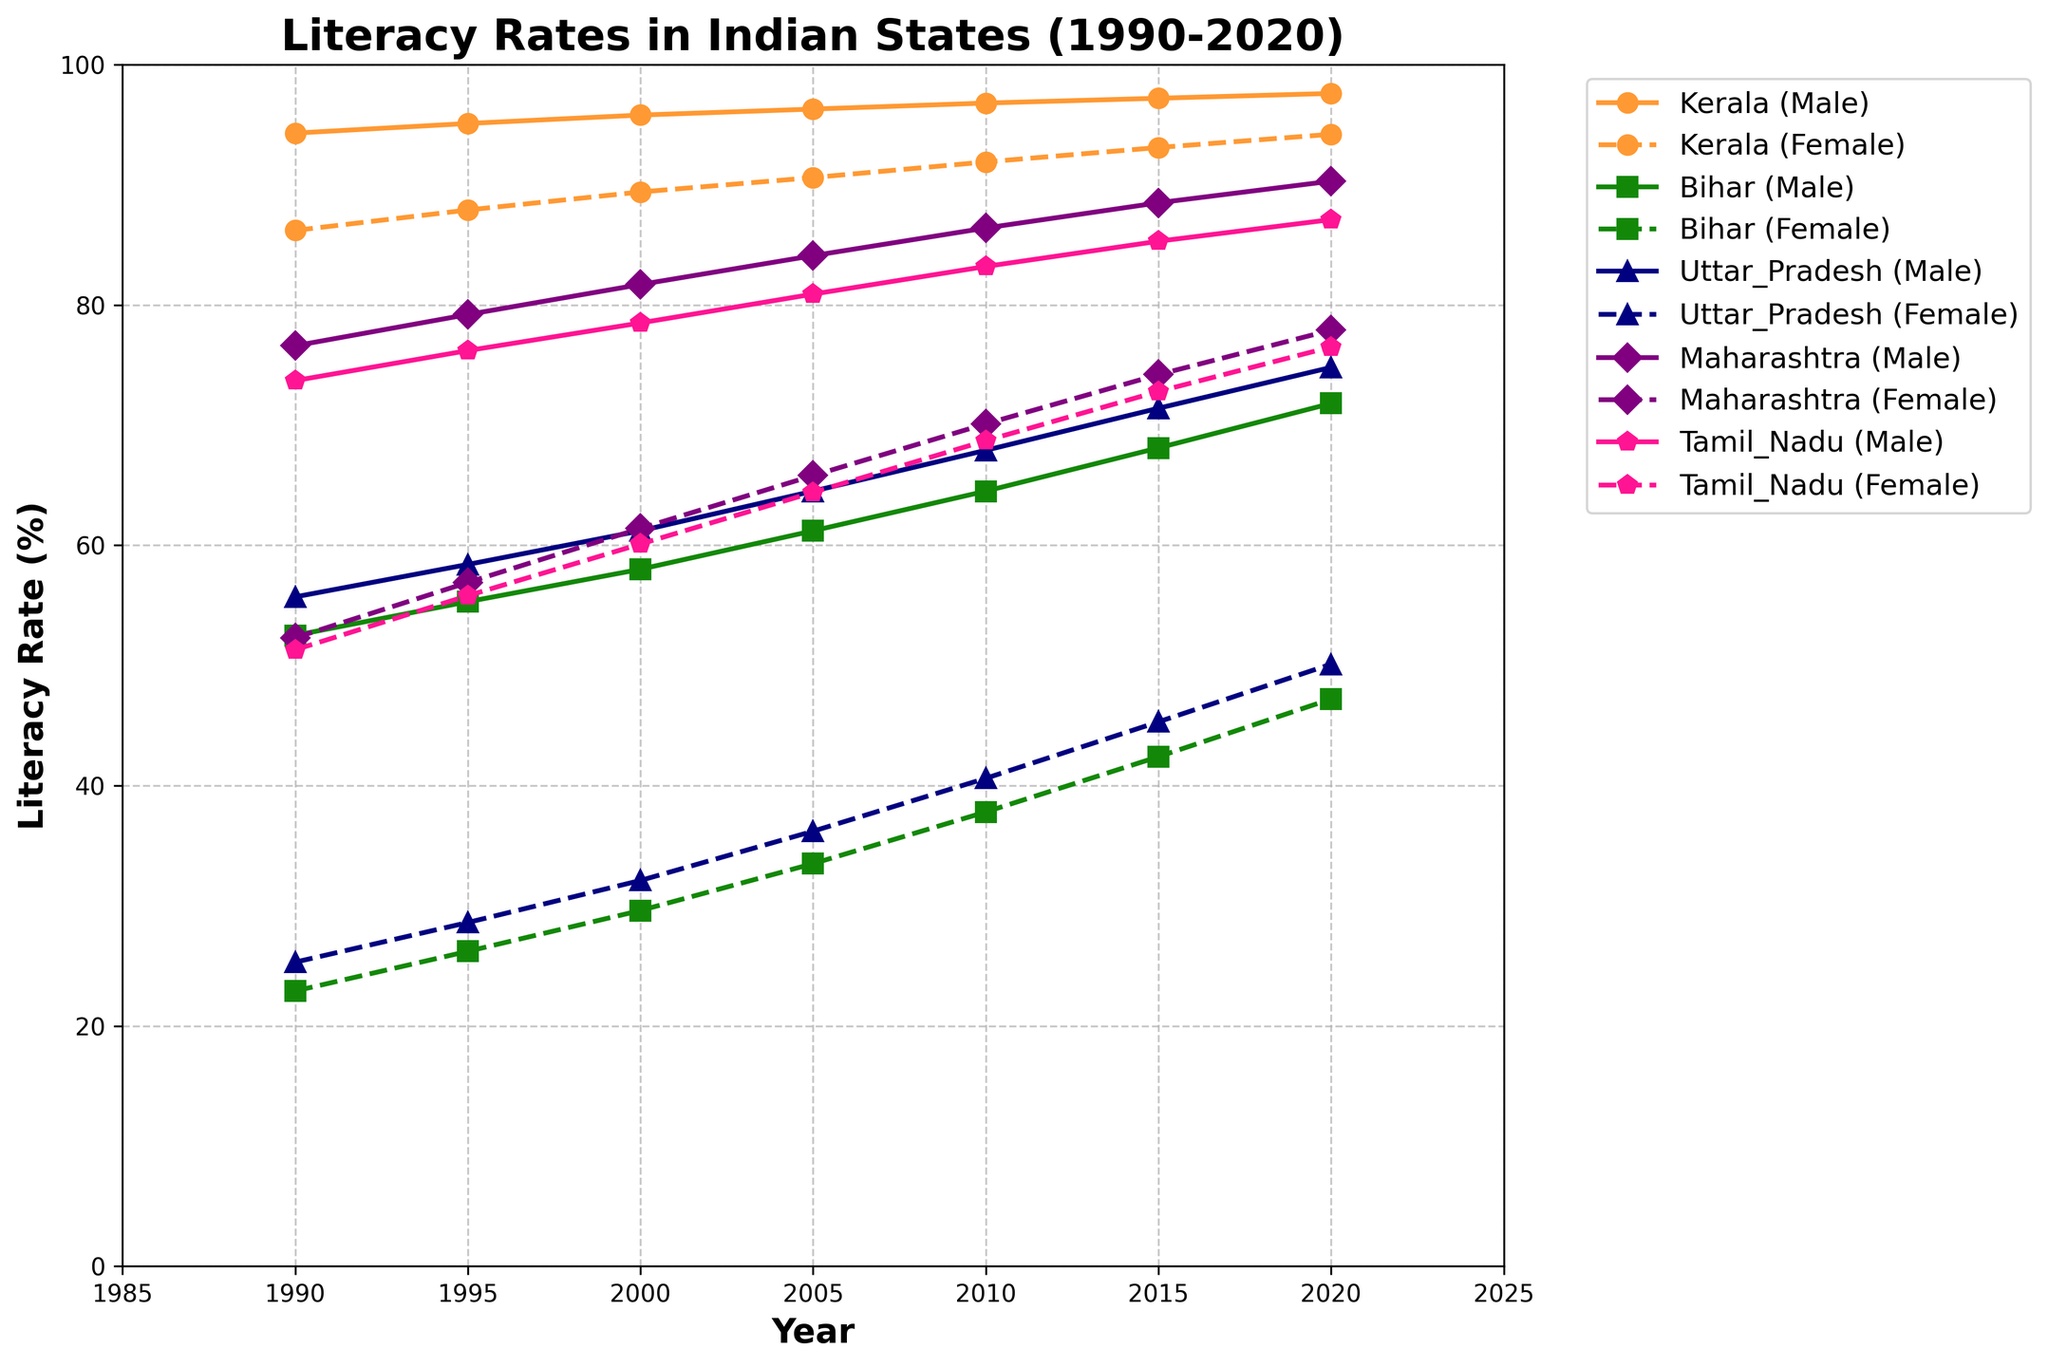Which state had the highest male literacy rate in 2020? Look at the lines representing male literacy rates for 2020; Kerala's male literacy rate is the highest at 97.6%.
Answer: Kerala Which states had female literacy rates above 75% in 2020? Check the lines for female literacy rates in 2020; Kerala (94.2%), Maharashtra (77.9%), and Tamil Nadu (76.5%) had rates above 75%.
Answer: Kerala, Maharashtra, Tamil Nadu In which year did Bihar's female literacy rate surpass 40%? Follow Bihar's female literacy line and look for the first year the rate exceeds 40%. This occurs in 2010.
Answer: 2010 How much did Uttar Pradesh's male literacy rate increase from 1990 to 2020? Subtract the 1990 value (55.7%) from the 2020 value (74.8%) for Uttar Pradesh males: 74.8% - 55.7% = 19.1%.
Answer: 19.1% In 2005, which state had the smallest gap between male and female literacy rates? Calculate the gaps for each state in 2005. Kerala: 96.3% - 90.6% = 5.7%, Bihar: 61.2% - 33.5% = 27.7%, Uttar Pradesh: 64.5% - 36.2% = 28.3%, Maharashtra: 84.1% - 65.8% = 18.3%, Tamil Nadu: 80.9% - 64.4% = 16.5%. Kerala has the smallest gap of 5.7%.
Answer: Kerala Which state showed the largest improvement in female literacy rates between 1990 and 2020? Calculate the difference between 1990 and 2020 for females in each state: Kerala (94.2% - 86.2% = 8.0%), Bihar (47.2% - 22.9% = 24.3%), Uttar Pradesh (50.1% - 25.3% = 24.8%), Maharashtra (77.9% - 52.3% = 25.6%), Tamil Nadu (76.5% - 51.3% = 25.2%). Maharashtra has the largest improvement of 25.6%.
Answer: Maharashtra Compare the female literacy rates of Tamil Nadu and Bihar in 1995. Which was higher and by how much? Tamil Nadu’s female literacy rate in 1995 was 55.8%, and Bihar’s was 26.2%. The difference is 55.8% - 26.2% = 29.6%.
Answer: Tamil Nadu by 29.6% Across all states, which female literacy rate showed the slowest growth between 1990 and 2020? Calculate (and compare) the twenty-year increases for each state: Kerala (94.2% - 86.2% = 8.0%), Bihar (47.2% - 22.9% = 24.3%), Uttar Pradesh (50.1% - 25.3% = 24.8%), Maharashtra (77.9% - 52.3% = 25.6%), Tamil Nadu (76.5% - 51.3% = 25.2%). Kerala’s 8.0% rise is the smallest.
Answer: Kerala In 2000, did any state's female literacy rate exceed Maharashtra's male literacy rate in 1990? Maharashtra's male literacy rate in 1990 was 76.6%. Comparing this to the female rates in 2000 shows no state exceeds 76.6% by 2000.
Answer: No Which year did Tamil Nadu's female literacy rate first surpass Bihar's male literacy rate in 1990? Compare Tamil Nadu females' rates across years to Bihar males' 1990 rate (52.5%). Tamil Nadu first exceeds this in 1995 when it reaches 55.8%.
Answer: 1995 